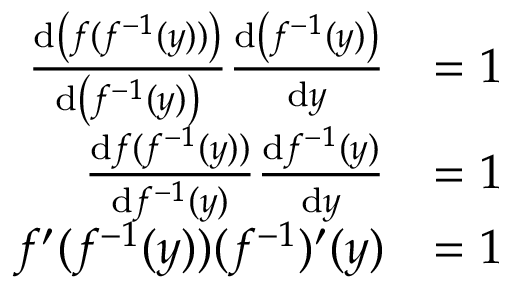Convert formula to latex. <formula><loc_0><loc_0><loc_500><loc_500>{ \begin{array} { r l } { { \frac { d \left ( f ( f ^ { - 1 } ( y ) ) \right ) } { d \left ( f ^ { - 1 } ( y ) \right ) } } { \frac { d \left ( f ^ { - 1 } ( y ) \right ) } { d y } } } & { = 1 } \\ { { \frac { d f ( f ^ { - 1 } ( y ) ) } { d f ^ { - 1 } ( y ) } } { \frac { d f ^ { - 1 } ( y ) } { d y } } } & { = 1 } \\ { f ^ { \prime } ( f ^ { - 1 } ( y ) ) ( f ^ { - 1 } ) ^ { \prime } ( y ) } & { = 1 } \end{array} }</formula> 